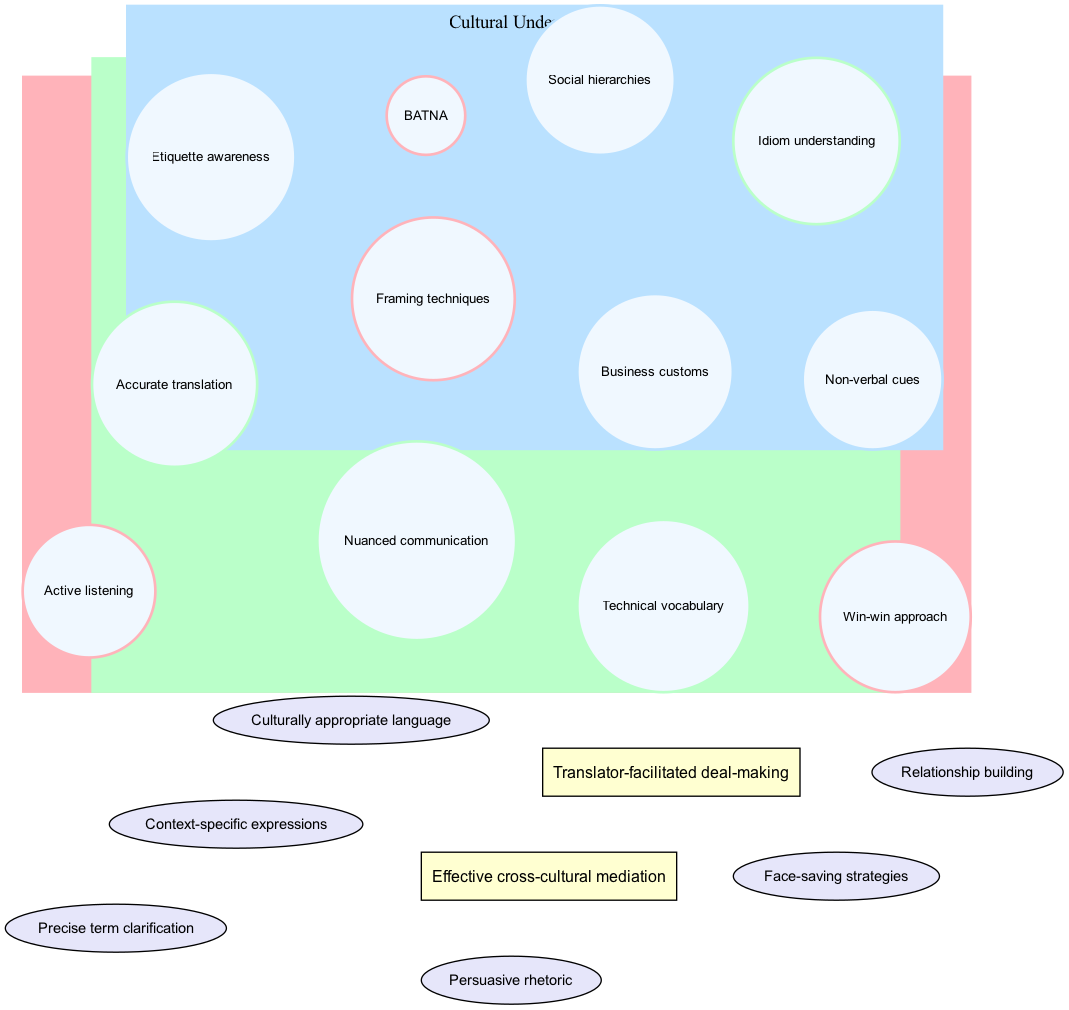What elements are included in the 'Language Proficiency' circle? The 'Language Proficiency' circle contains these elements: Accurate translation, Idiom understanding, Technical vocabulary, and Nuanced communication. I find these by focusing on the section of the diagram labeled 'Language Proficiency' which lists its components.
Answer: Accurate translation, Idiom understanding, Technical vocabulary, Nuanced communication How many elements are in the 'Negotiation Strategies' circle? The 'Negotiation Strategies' circle has four elements: BATNA, Win-win approach, Active listening, and Framing techniques. Counting the listed components in that section confirms the total.
Answer: 4 What is the central overlap labeled? The central overlap area of the diagram is labeled 'Central Overlap', which is confirmed by looking at the region where all three circles intersect.
Answer: Central Overlap Which two elements are found in the overlap between 'Language' and 'Culture'? The elements in the overlap between 'Language' and 'Culture' are Context-specific expressions and Culturally appropriate language. This information is derived by examining the shared section specifically labeled for those two circles.
Answer: Context-specific expressions, Culturally appropriate language What strategy is mentioned in the overlap between 'Negotiation' and 'Culture'? The strategies mentioned in the overlap of 'Negotiation' and 'Culture' are Face-saving strategies and Relationship building, found by analyzing the nodes that connect these two specific circles in the diagram.
Answer: Face-saving strategies, Relationship building How many total circles are illustrated in the diagram? There are three main circles illustrated in the diagram, identified by counting the distinct labeled areas for 'Negotiation Strategies', 'Language Proficiency', and 'Cultural Understanding'.
Answer: 3 What is one element of the 'Negotiation Strategies' circle that promotes a collaborative outcome? The element that promotes a collaborative outcome in the 'Negotiation Strategies' circle is the Win-win approach, which is clearly stated as one of the components of that circle.
Answer: Win-win approach Which element suggests a technique that incorporates the use of skilled communication? The element 'Persuasive rhetoric' in the overlap between 'Negotiation' and 'Language' suggests a technique that incorporates the use of skilled communication, identified by analyzing the intersection dedicated to both circles.
Answer: Persuasive rhetoric What is the overall theme represented in the central overlap? The overall theme represented in the central overlap is 'Effective cross-cultural mediation', indicating a focus on the intersection of negotiation, language, and culture in facilitating successful interactions. This is apparent from the specific label in that central area.
Answer: Effective cross-cultural mediation 